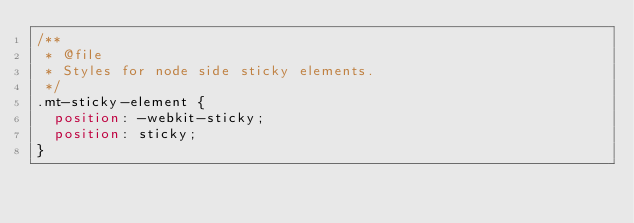<code> <loc_0><loc_0><loc_500><loc_500><_CSS_>/**
 * @file
 * Styles for node side sticky elements.
 */
.mt-sticky-element {
  position: -webkit-sticky;
  position: sticky;
}</code> 